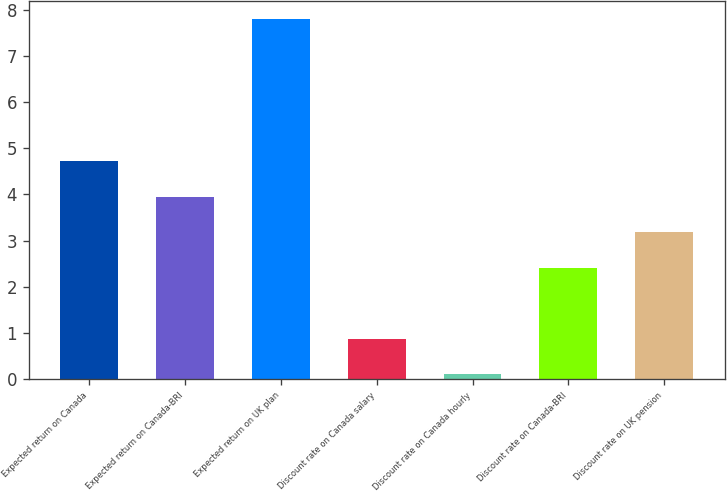<chart> <loc_0><loc_0><loc_500><loc_500><bar_chart><fcel>Expected return on Canada<fcel>Expected return on Canada-BRI<fcel>Expected return on UK plan<fcel>Discount rate on Canada salary<fcel>Discount rate on Canada hourly<fcel>Discount rate on Canada-BRI<fcel>Discount rate on UK pension<nl><fcel>4.72<fcel>3.95<fcel>7.8<fcel>0.87<fcel>0.1<fcel>2.41<fcel>3.18<nl></chart> 